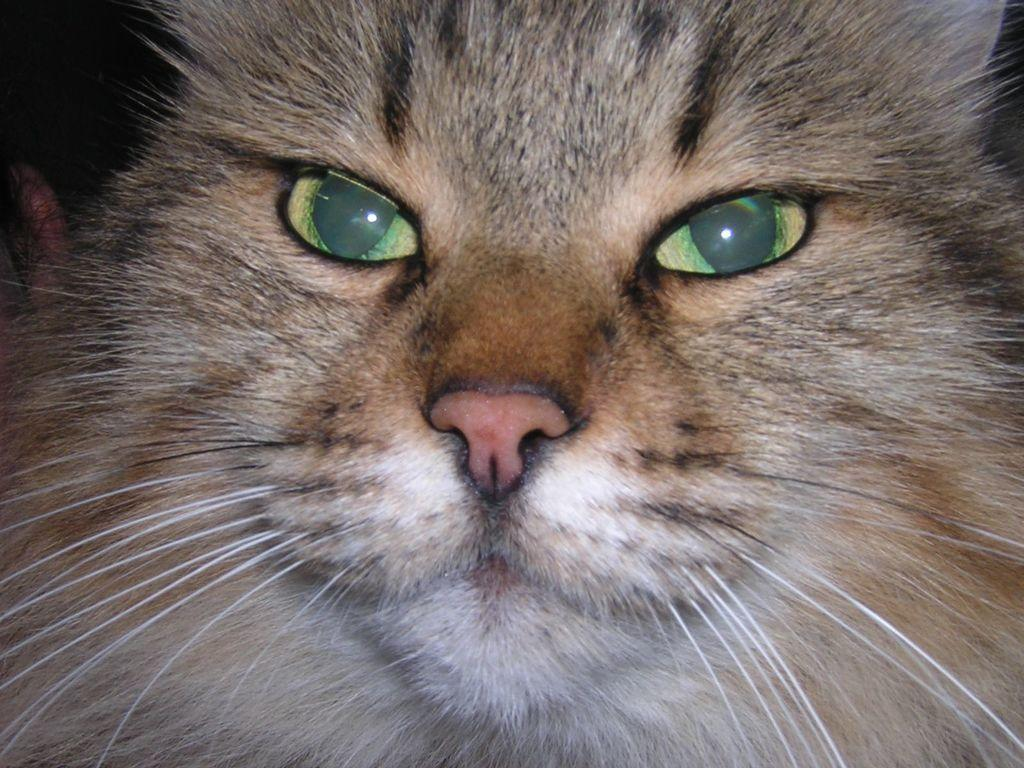What is the main subject of the image? The main subject of the image is the face of a cat. What type of kettle is being used to apply paste to the cat's face in the image? There is no kettle or paste present in the image; it only features the face of a cat. 